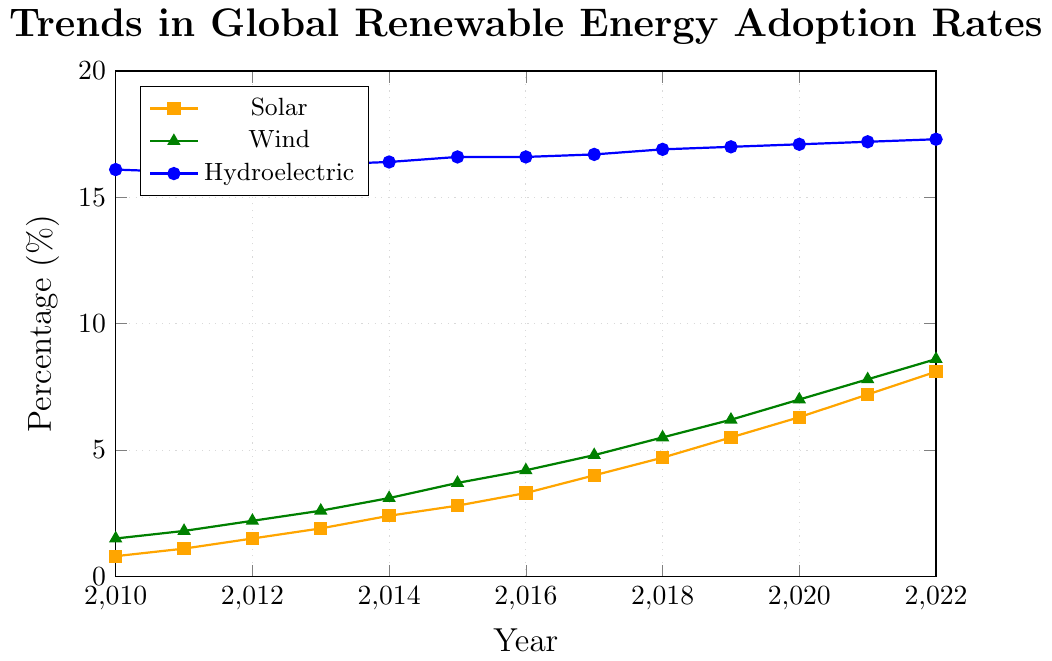What's the overall trend in Solar adoption rates from 2010 to 2022? The Solar adoption rates show a steady increase from 0.8% in 2010 to 8.1% in 2022. Each year, the percentage goes up, illustrating a consistent upward trend.
Answer: Steady increase By how much did Wind adoption rates increase from 2015 to 2020? Wind adoption rates were 3.7% in 2015 and 7.0% in 2020. The difference is calculated by subtracting the 2015 value from the 2020 value: 7.0% - 3.7% = 3.3%.
Answer: 3.3% Which renewable energy source had the lowest rate of change between 2010 and 2022? To find the renewable energy source with the lowest rate of change, we compare the differences over the years: Solar (8.1% - 0.8% = 7.3%), Wind (8.6% - 1.5% = 7.1%), and Hydroelectric (17.3% - 16.1% = 1.2%). Hydroelectric had the lowest rate of change.
Answer: Hydroelectric In which year do Solar and Wind adoption rates both surpass 4%? From the figure, we can see that in 2017 the Solar adoption rate is at 4.0% and the Wind adoption rate is at 4.8%, both surpassing the 4% mark.
Answer: 2017 What's the total adoption rate of Solar and Wind energy combined in 2022? The Solar adoption rate in 2022 is 8.1% and Wind's is 8.6%. Adding them together: 8.1% + 8.6% = 16.7%.
Answer: 16.7% Which energy source showed the most consistent upward trend from 2010 to 2022? By examining the slopes and y-values of the trends, both Solar and Wind show consistent upward trends, but given the smoother and steadily increasing slopes, Solar shows a more consistent upward trend without any declines.
Answer: Solar Compare the growth rates of Solar and Wind from 2010 to 2022. Which had a higher increase? Solar increased from 0.8% to 8.1% (7.3% increase), and Wind increased from 1.5% to 8.6% (7.1% increase). Solar showed a marginally higher increase.
Answer: Solar Does any energy source show a decline in adoption in any year? Hydroelectric shows a slight decrease from 16.1% in 2010 to 16.0% in 2011. Solar and Wind do not show any decline for any year.
Answer: Hydroelectric What is the difference in Hydroelectric adoption rates between 2010 and 2022? Hydroelectric adoption rates were 16.1% in 2010 and 17.3% in 2022. The difference is calculated by subtracting the 2010 value from the 2022 value: 17.3% - 16.1% = 1.2%.
Answer: 1.2% What was the average adoption rate of Wind energy over the given period? To find the average, sum the Wind values and divide by the number of years: (1.5 + 1.8 + 2.2 + 2.6 + 3.1 + 3.7 + 4.2 + 4.8 + 5.5 + 6.2 + 7.0 + 7.8 + 8.6) / 13 = 4.53%.
Answer: 4.53% 